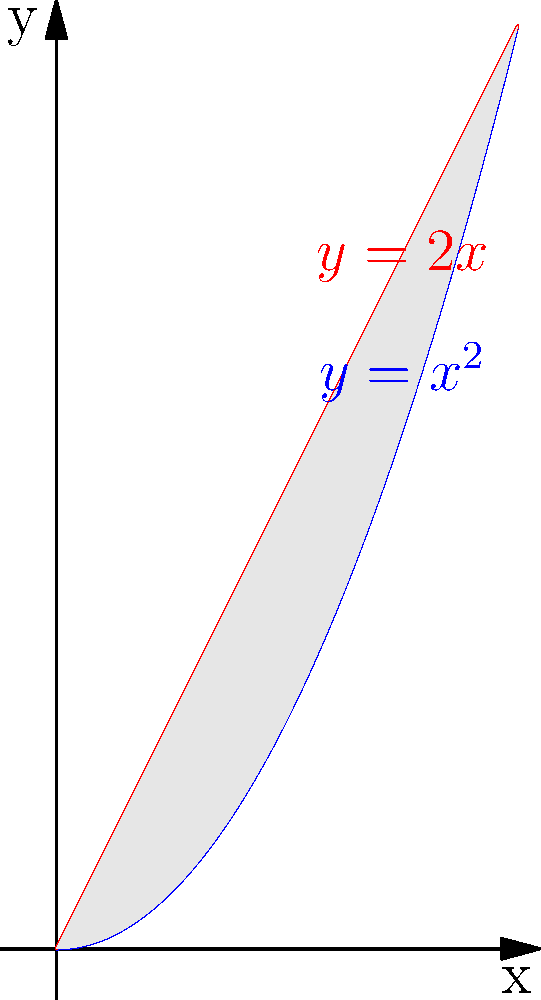As a fellow representative passionate about addressing user needs, you're tasked with explaining a calculus concept to a group of engineering students. Consider the graph shown, where the blue curve represents $y=x^2$ and the red line represents $y=2x$. Calculate the area of the region bounded by these two curves. Let's approach this step-by-step:

1) First, we need to find the points of intersection of the two curves:
   $x^2 = 2x$
   $x^2 - 2x = 0$
   $x(x - 2) = 0$
   So, $x = 0$ or $x = 2$

2) The area we're looking for is the difference between the integral of the upper function and the lower function from $x = 0$ to $x = 2$:

   $$ A = \int_0^2 (2x - x^2) dx $$

3) Let's integrate:
   $$ A = \int_0^2 (2x - x^2) dx = [x^2 - \frac{x^3}{3}]_0^2 $$

4) Now we evaluate the integral at the limits:
   $$ A = (2^2 - \frac{2^3}{3}) - (0^2 - \frac{0^3}{3}) $$
   $$ A = (4 - \frac{8}{3}) - 0 $$
   $$ A = \frac{12}{3} - \frac{8}{3} = \frac{4}{3} $$

5) Therefore, the area between the curves is $\frac{4}{3}$ square units.
Answer: $\frac{4}{3}$ square units 